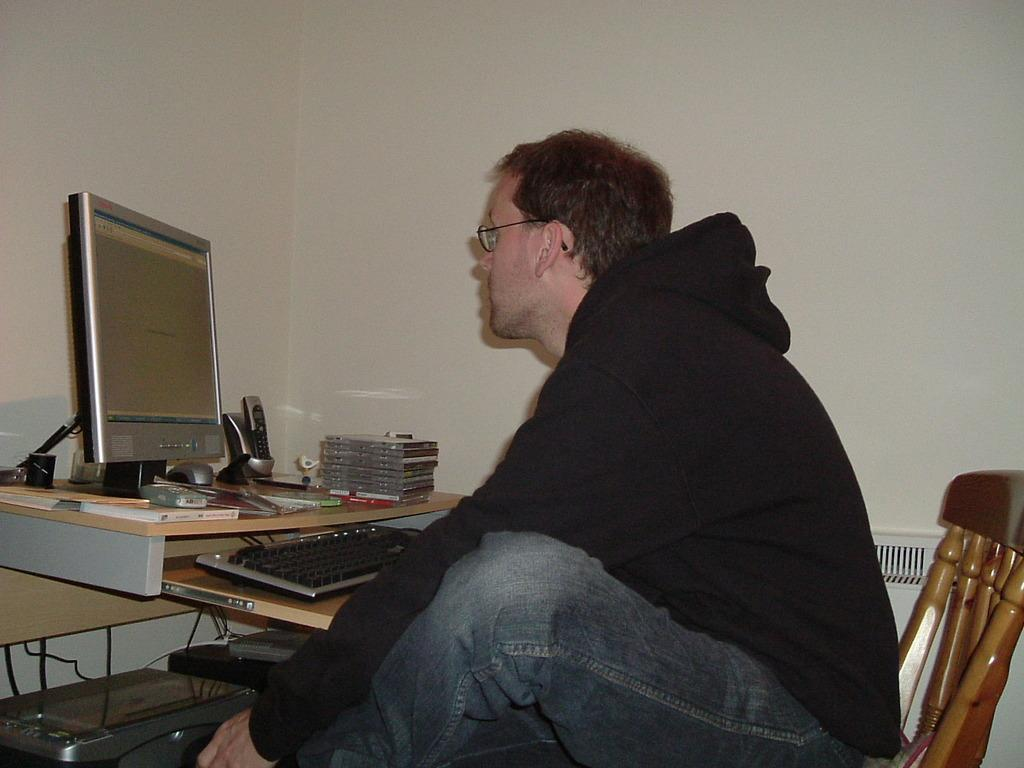What is the person in the image doing? The person is sitting on a chair in the image. What is located near the person? There is a table in the image. What electronic devices are on the table? A computer and a mobile phone are on the table, along with other devices. What can be seen behind the person and table? There is a wall visible in the image. What temperature is the room in the image? The provided facts do not mention the temperature of the room, so it cannot be determined from the image. 